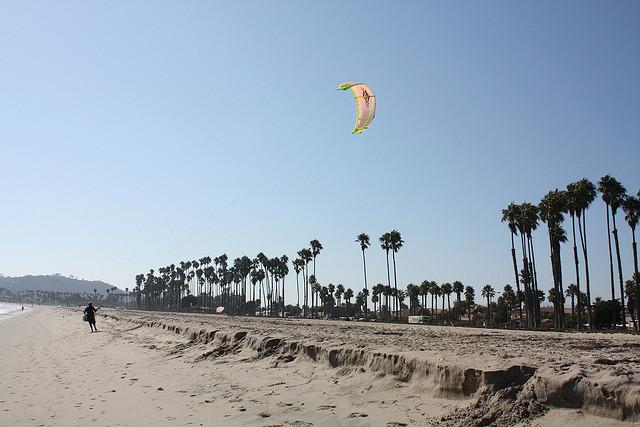What side of the beach is the water on?
Concise answer only. Left. What fruit does the object in the sky resemble?
Quick response, please. Banana. Where is this scene?
Quick response, please. Beach. Are the trees black?
Keep it brief. No. 